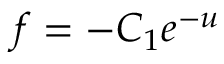<formula> <loc_0><loc_0><loc_500><loc_500>f = - C _ { 1 } e ^ { - u }</formula> 